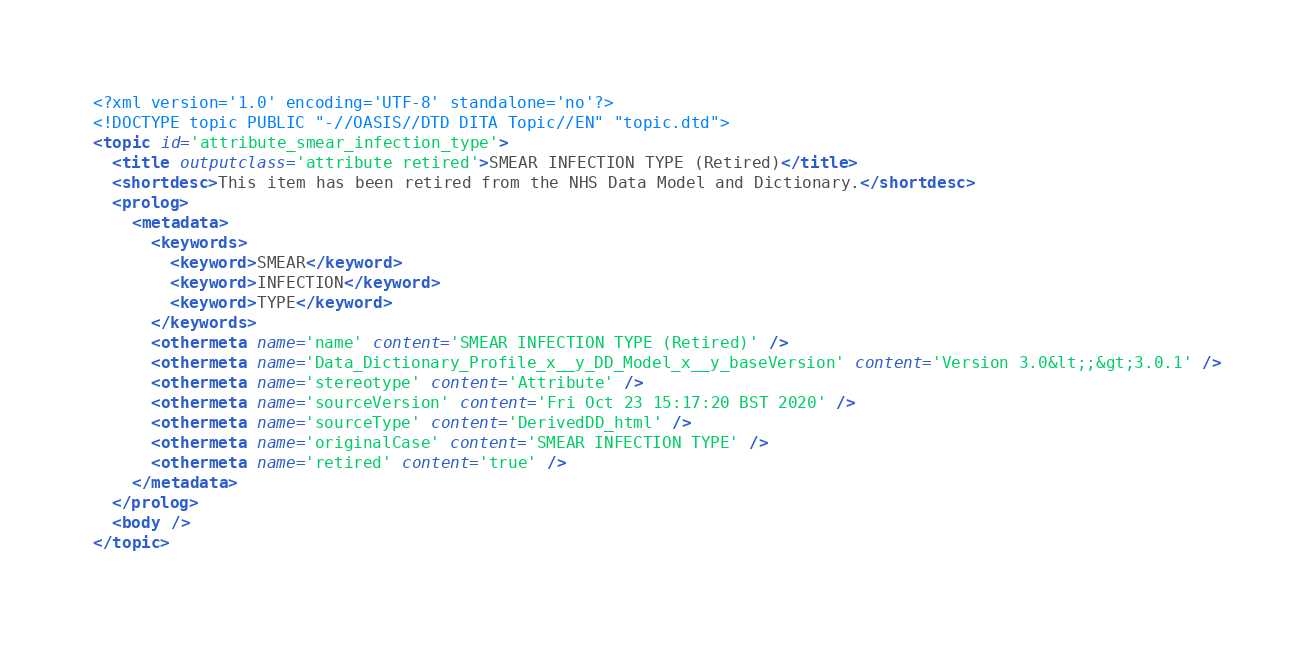Convert code to text. <code><loc_0><loc_0><loc_500><loc_500><_XML_><?xml version='1.0' encoding='UTF-8' standalone='no'?>
<!DOCTYPE topic PUBLIC "-//OASIS//DTD DITA Topic//EN" "topic.dtd">
<topic id='attribute_smear_infection_type'>
  <title outputclass='attribute retired'>SMEAR INFECTION TYPE (Retired)</title>
  <shortdesc>This item has been retired from the NHS Data Model and Dictionary.</shortdesc>
  <prolog>
    <metadata>
      <keywords>
        <keyword>SMEAR</keyword>
        <keyword>INFECTION</keyword>
        <keyword>TYPE</keyword>
      </keywords>
      <othermeta name='name' content='SMEAR INFECTION TYPE (Retired)' />
      <othermeta name='Data_Dictionary_Profile_x__y_DD_Model_x__y_baseVersion' content='Version 3.0&lt;;&gt;3.0.1' />
      <othermeta name='stereotype' content='Attribute' />
      <othermeta name='sourceVersion' content='Fri Oct 23 15:17:20 BST 2020' />
      <othermeta name='sourceType' content='DerivedDD_html' />
      <othermeta name='originalCase' content='SMEAR INFECTION TYPE' />
      <othermeta name='retired' content='true' />
    </metadata>
  </prolog>
  <body />
</topic></code> 